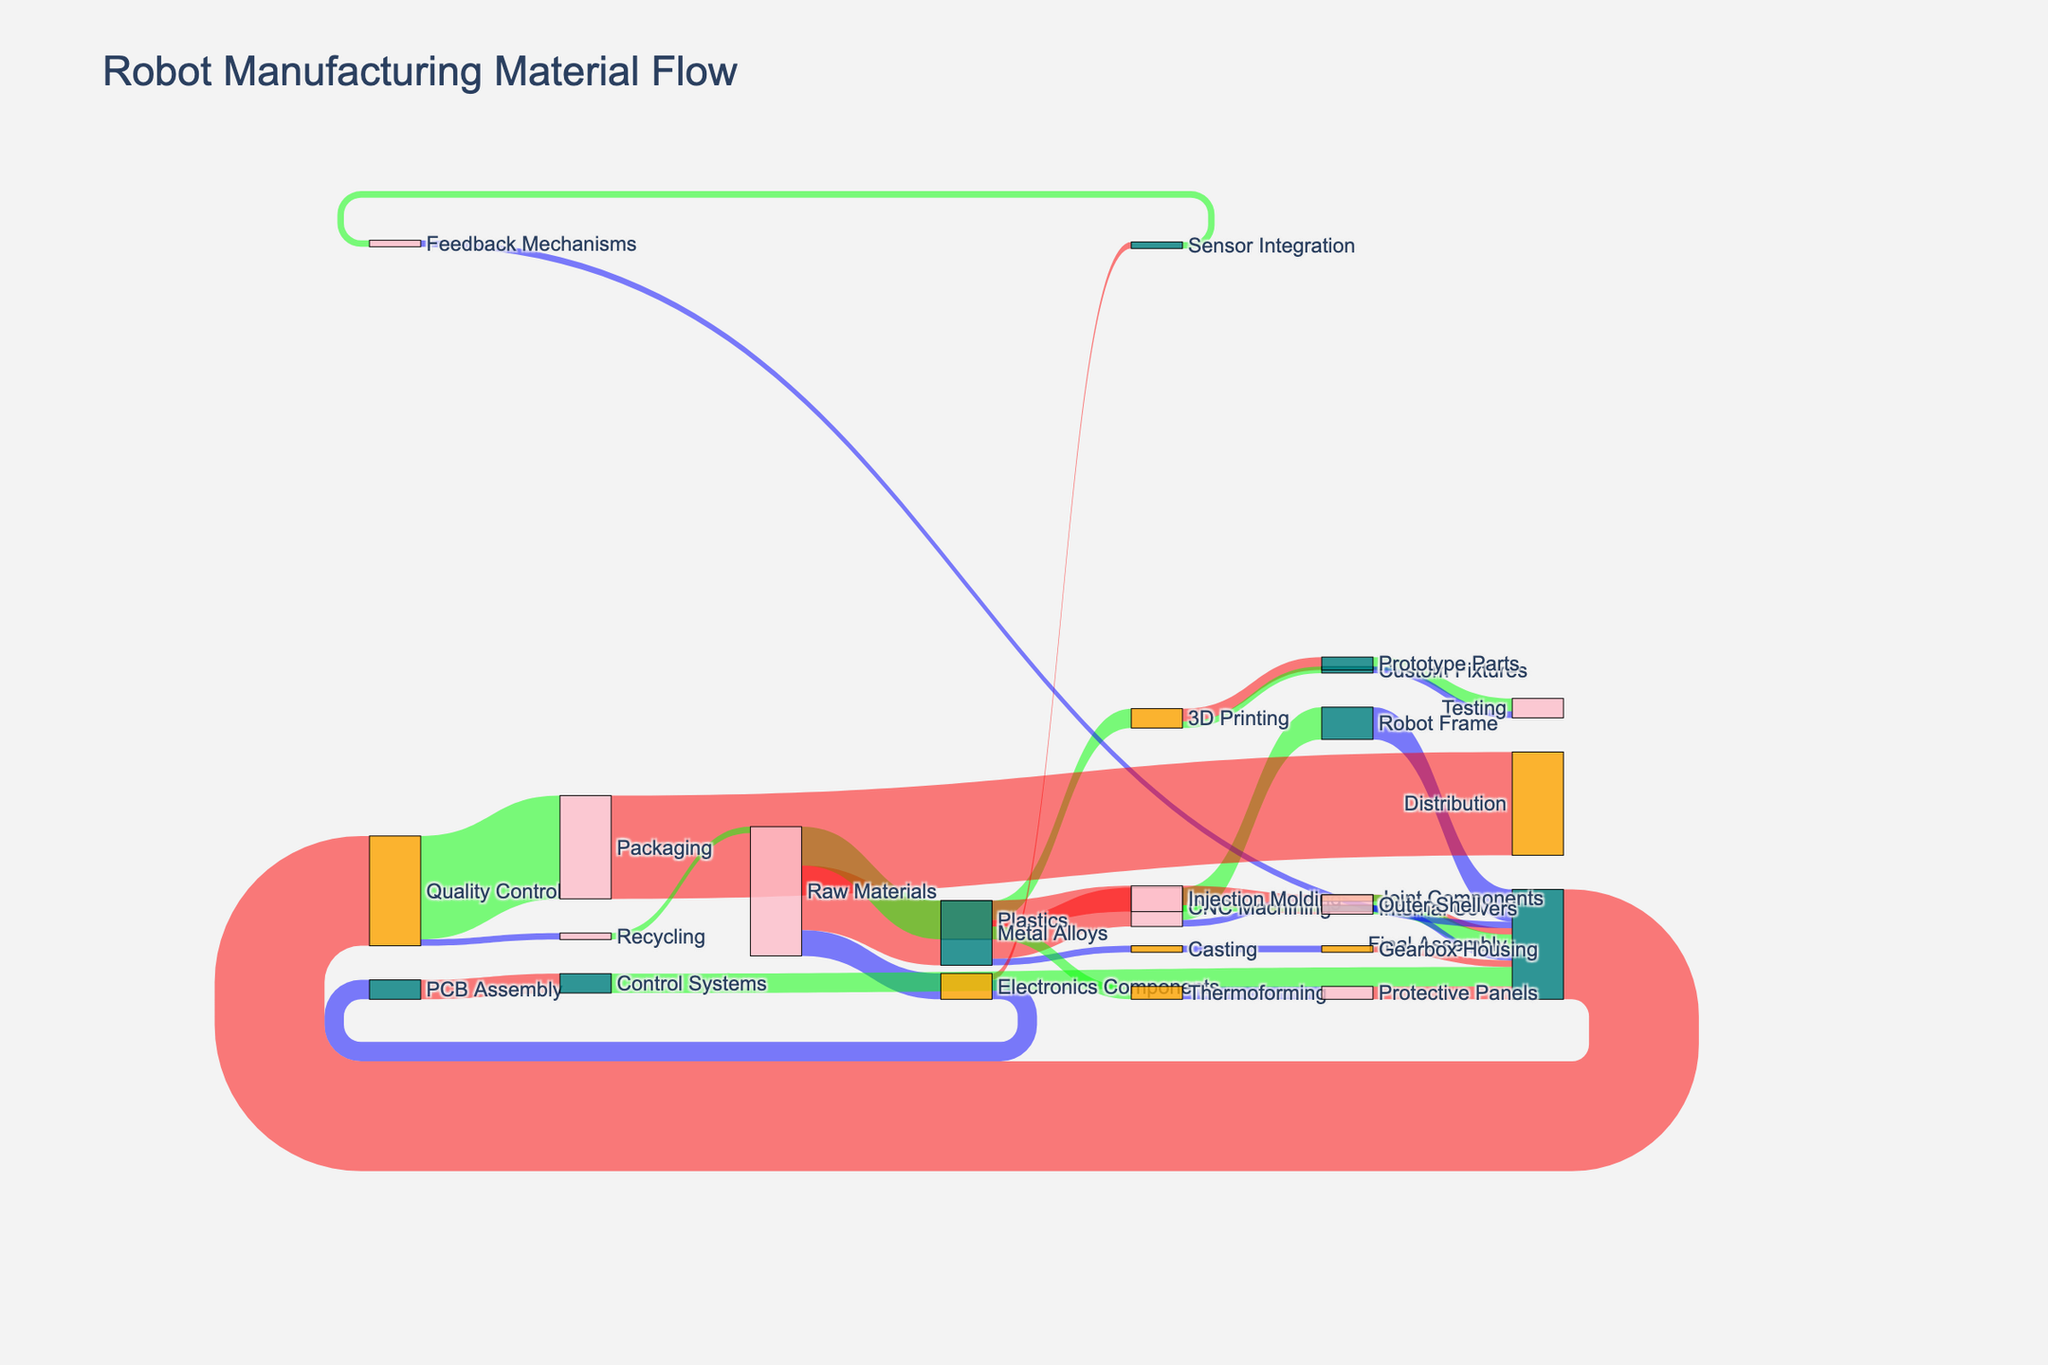What are the three main raw materials used in robot manufacturing? The diagram indicates that the three raw materials are Metal Alloys, Plastics, and Electronics Components, as they all originate from the Raw Materials node.
Answer: Metal Alloys, Plastics, Electronics Components What is the total amount of material flowing to the CNC Machining stage? The sum of material values flowing to CNC Machining includes 300 units from Metal Alloys. This can be directly observed from the diagram.
Answer: 300 Which manufacturing process uses the most Plastics? By examining the links from Plastics, Injection Molding uses 200 units, and Thermoforming uses 100 units. Therefore, Injection Molding uses the most Plastics.
Answer: Injection Molding What is the most frequent destination of Metal Alloys after the initial processing stages? The diagram shows material flows from Metal Alloys to CNC Machining (300 units), 3D Printing (150 units), and Casting (50 units). CNC Machining receives the largest flow of 300 units.
Answer: CNC Machining How much material is recycled back to Raw Materials? According to the diagram, Recycling node sends 50 units back to the Raw Materials node. This is observed by following the flow from Recycling to Raw Materials.
Answer: 50 From PCB Assembly, how much material is used in Control Systems, and how much continues to the Final Assembly? All material (150 units) from PCB Assembly goes into Control Systems, which then all flow into Final Assembly. Thus, 150 units flow from PCB Assembly to Final Assembly via Control Systems.
Answer: 150 At the Quality Control stage, what amount of material flows to Packaging, and what amount to Recycling? Following the flows from Quality Control, 800 units go to Packaging, and 50 units go to Recycling. This is directly indicated in the diagram.
Answer: Packaging: 800, Recycling: 50 After the Final Assembly, which product has the second largest material input for packaging? The largest input for packaging is from Final Assembly (800 units). The second largest input cannot be directly discerned from the final stage information alone since Final Assembly aggregates all inputs. The only flow from Final Assembly to Packaging deals with the entire assembled robot, summing 800 units.
Answer: Complete Robot (inferred assembly line) Which stage has the highest outflow into the Final Assembly stage? Examining the flows to Final Assembly, the highest contributor is Robot Frame with 250 units, followed by Outer Shell and Control Systems, each with 150 units.
Answer: Robot Frame What is the total amount of materials processed by Injection Molding? The flows from Plastics to Injection Molding total 200 units, and this is directly read from the diagram.
Answer: 200 